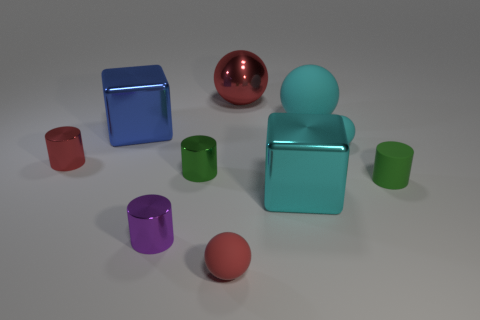There is another matte cylinder that is the same size as the red cylinder; what color is it? The other matte cylinder that matches the size of the red one is a serene shade of green. 